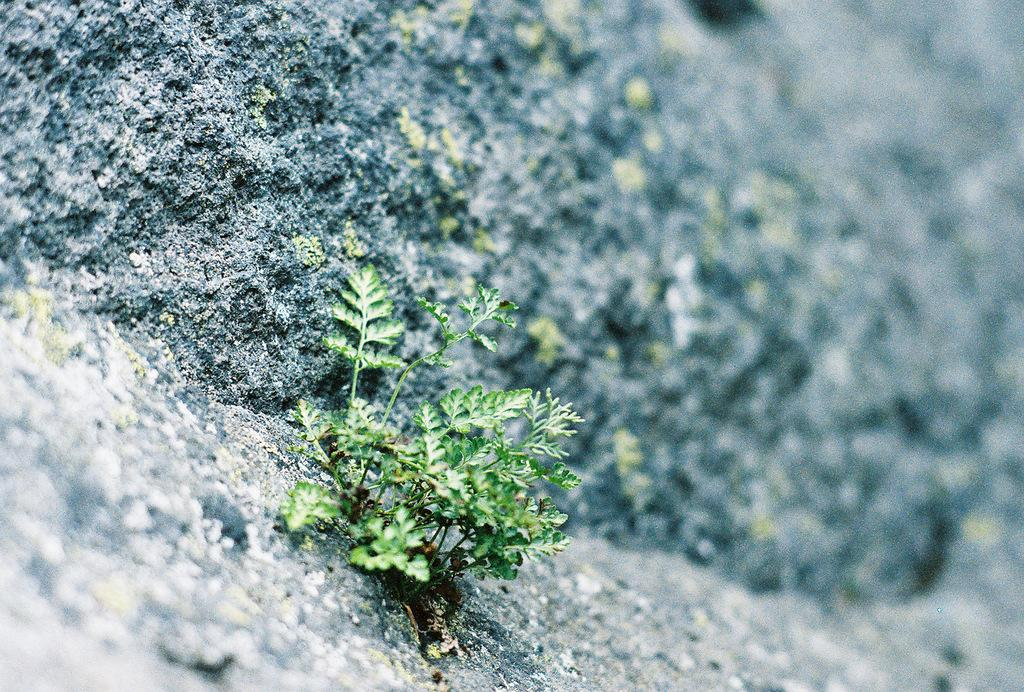What type of plant can be seen in the image? There is a green color plant in the image. What other object can be seen in the image? There is a black color rock in the image. Where is the hole in the image, and what type of berry is growing from it? There is no hole or berry present in the image; it only features a green color plant and a black color rock. 